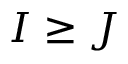Convert formula to latex. <formula><loc_0><loc_0><loc_500><loc_500>I \geq J</formula> 